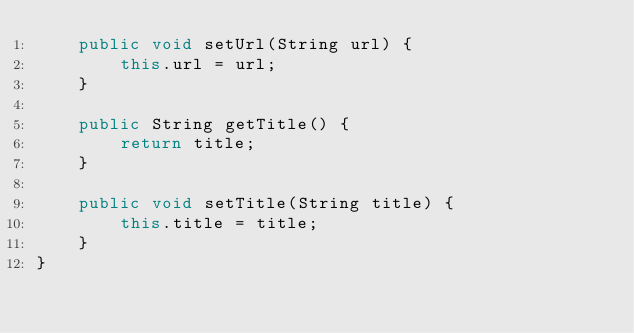Convert code to text. <code><loc_0><loc_0><loc_500><loc_500><_Java_>    public void setUrl(String url) {
        this.url = url;
    }

    public String getTitle() {
        return title;
    }

    public void setTitle(String title) {
        this.title = title;
    }
}
</code> 